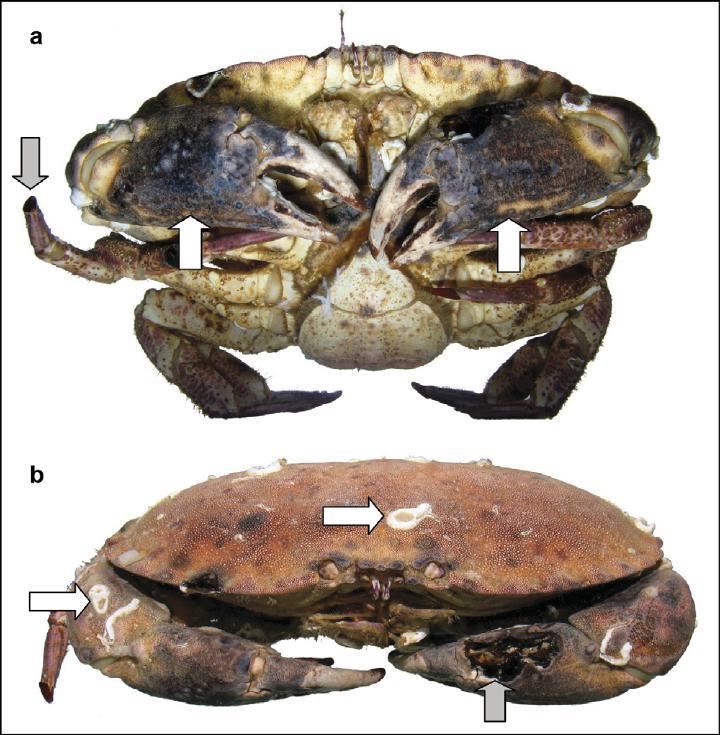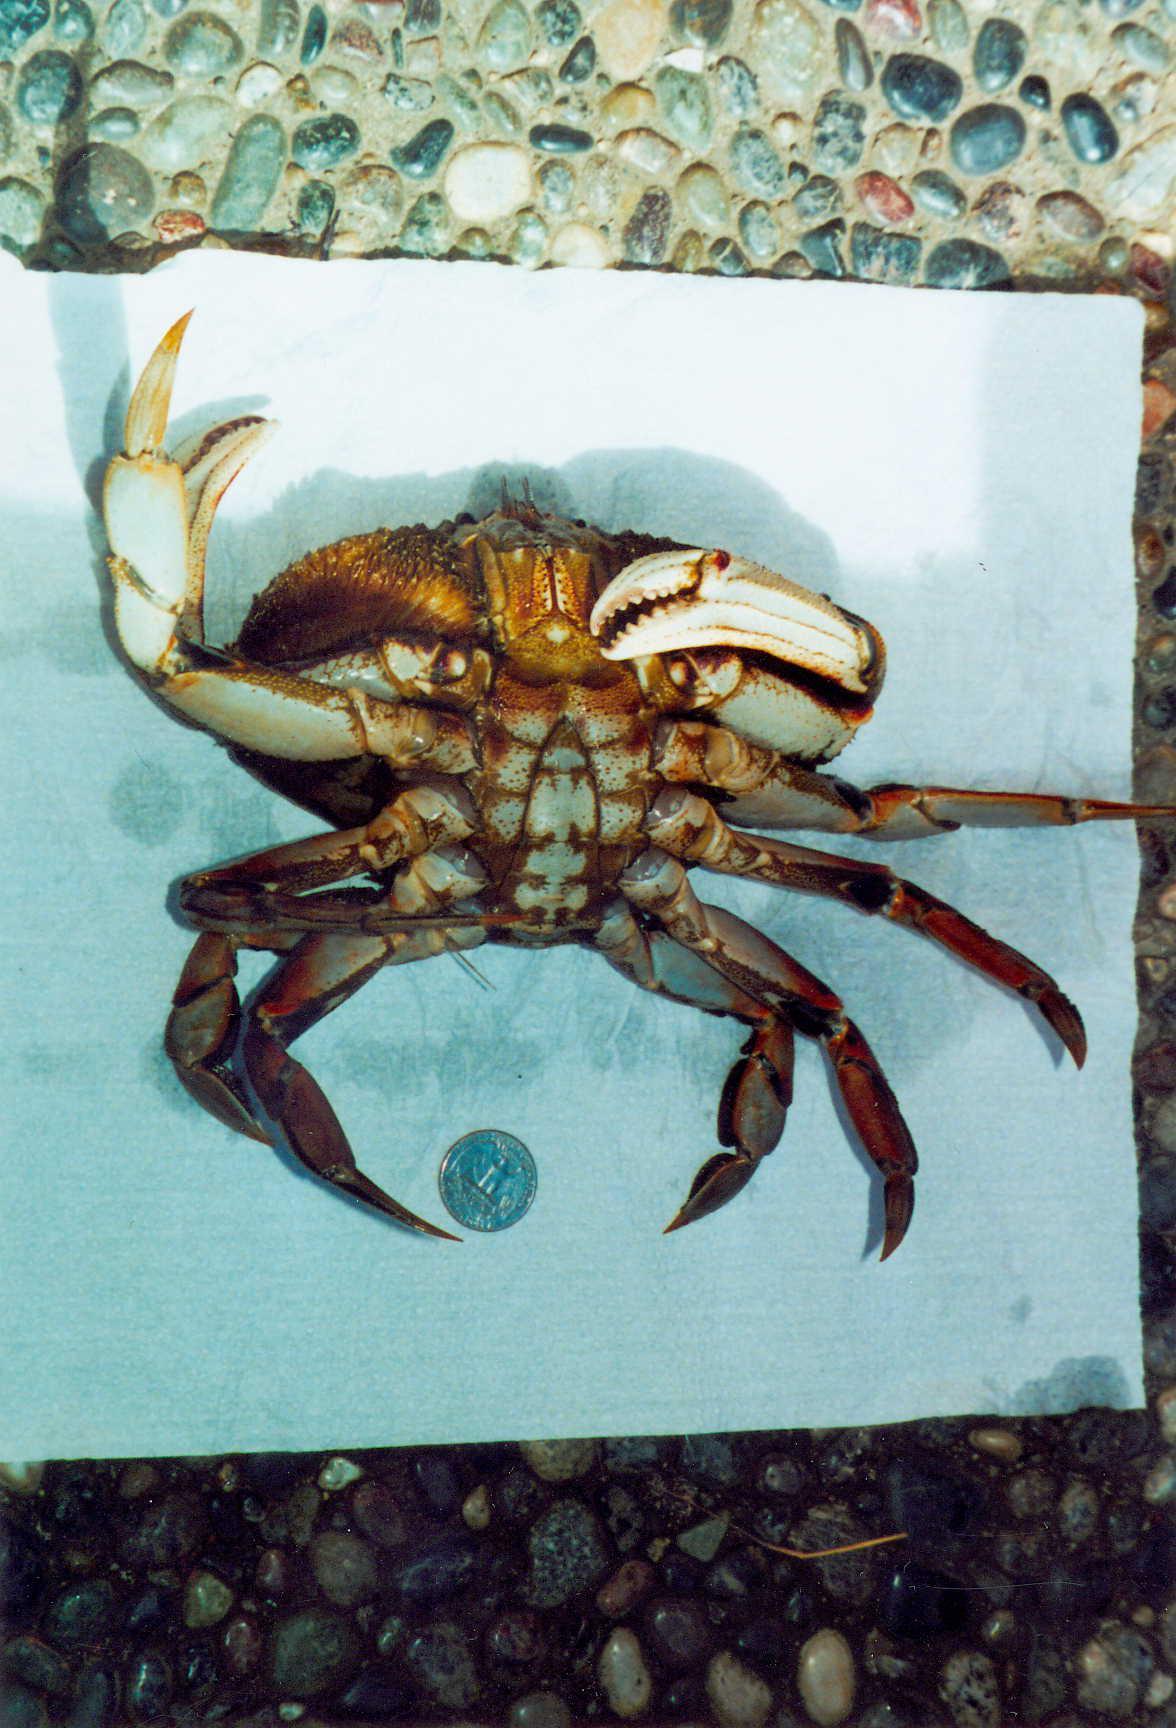The first image is the image on the left, the second image is the image on the right. For the images displayed, is the sentence "There are exactly two crabs." factually correct? Answer yes or no. No. The first image is the image on the left, the second image is the image on the right. For the images displayed, is the sentence "An image shows a ruler displayed horizontally under a crab facing forward." factually correct? Answer yes or no. No. 